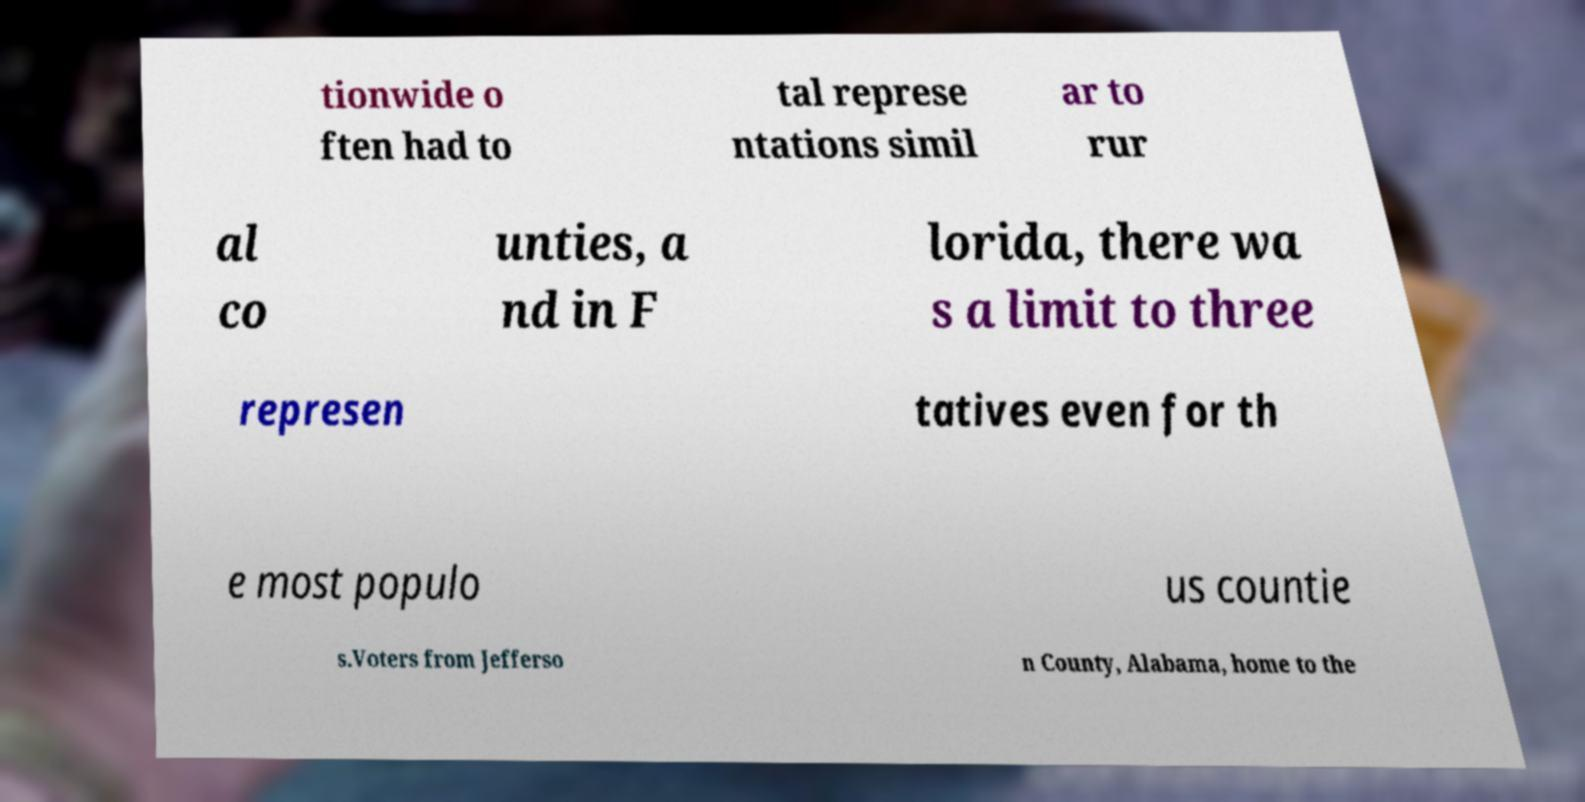Can you accurately transcribe the text from the provided image for me? tionwide o ften had to tal represe ntations simil ar to rur al co unties, a nd in F lorida, there wa s a limit to three represen tatives even for th e most populo us countie s.Voters from Jefferso n County, Alabama, home to the 